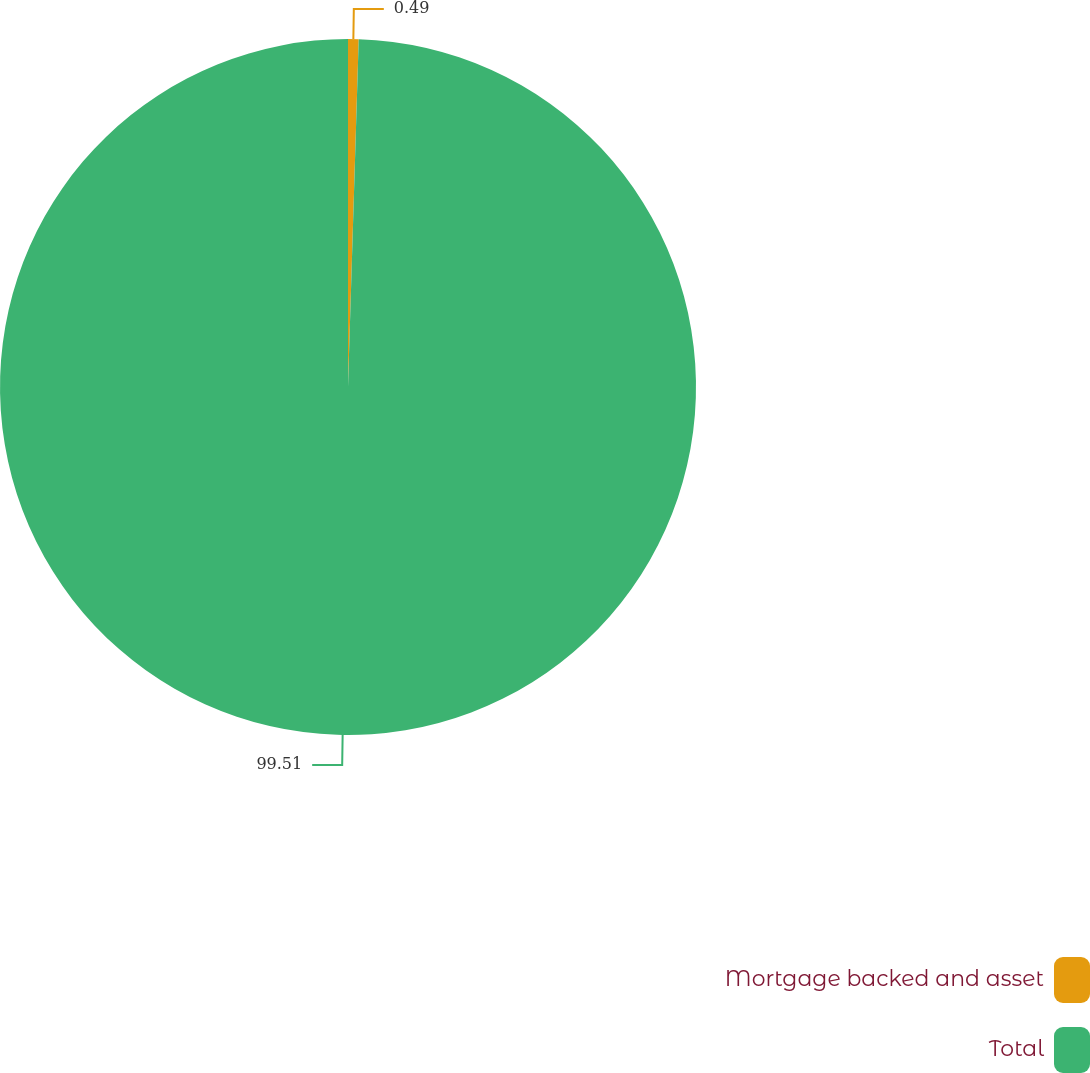Convert chart to OTSL. <chart><loc_0><loc_0><loc_500><loc_500><pie_chart><fcel>Mortgage backed and asset<fcel>Total<nl><fcel>0.49%<fcel>99.51%<nl></chart> 